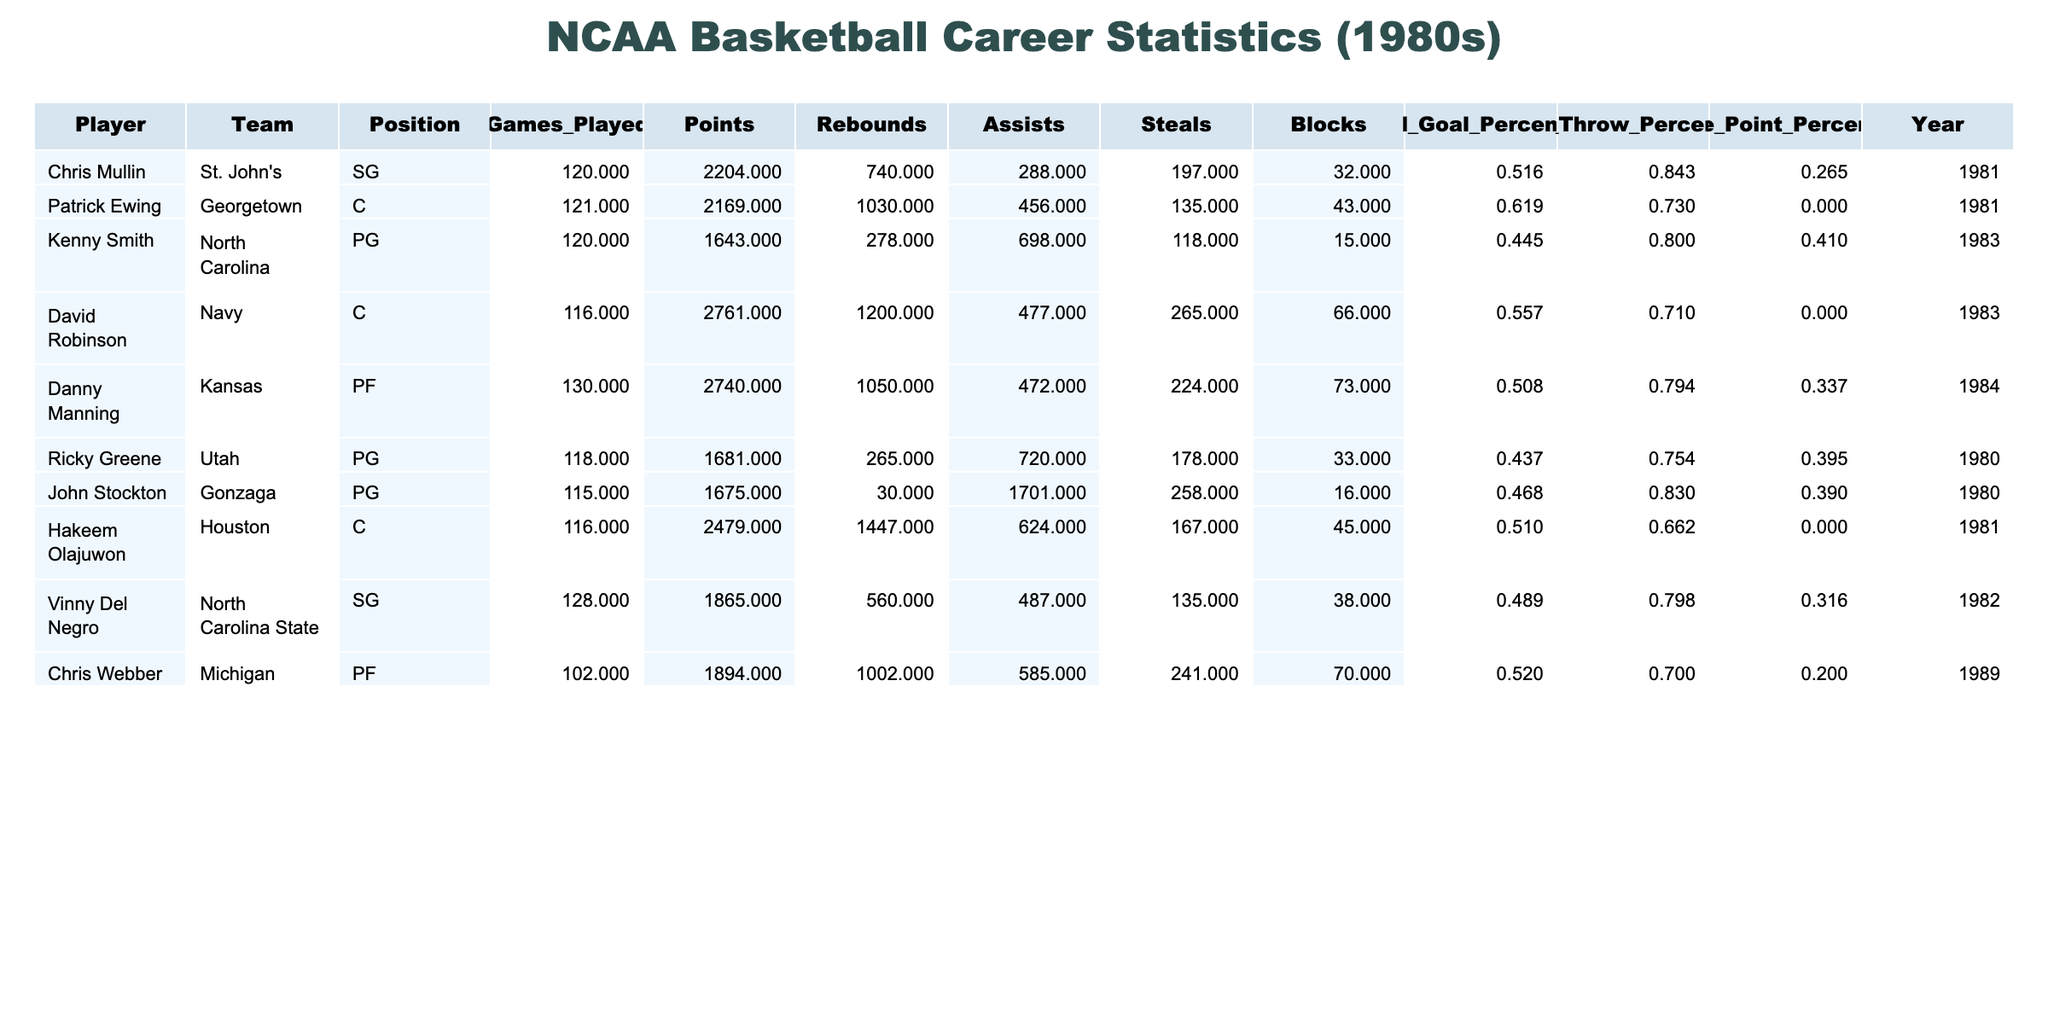What is the total number of points scored by David Robinson? David Robinson scored a total of 2761 points, which is listed in the table under the "Points" column for his entry.
Answer: 2761 Which player has the highest field goal percentage? Looking at the "Field_Goal_Percentage" column, Patrick Ewing has the highest field goal percentage of 0.619.
Answer: 0.619 How many rebounds did Chris Mullin record in his career? The table indicates that Chris Mullin recorded 740 rebounds, found in the "Rebounds" column for his entry.
Answer: 740 What is the average points scored by the players in this dataset? To find the average, we sum the points: (2204 + 2169 + 1643 + 2761 + 2740 + 1681 + 1675 + 2479 + 1865 + 1894) = 19655. There are 10 players, so the average is 19655/10 = 1965.5.
Answer: 1965.5 Did any player achieve a three-point percentage higher than 0.4? Looking at the "Three_Point_Percentage" column, Kenny Smith and Ricky Greene both scored above 0.4, thus the answer is yes.
Answer: Yes Which player recorded the most assists? By examining the "Assists" column, we see that John Stockton recorded the most assists with 1701.
Answer: 1701 What is the sum of rebounds by all the players listed? To find the total rebounds, we add: (740 + 456 + 278 + 1200 + 472 + 265 + 30 + 624 + 560 + 585) = 4680.
Answer: 4680 Which players had more than 1000 points and greater than 700 assists? Examining players, David Robinson (2761 points, 477 assists) qualifies but not others, because no one else meets the dual criteria.
Answer: David Robinson What is the median free throw percentage for the players? To find the median, we list the free throw percentages in order: [0.662, 0.710, 0.730, 0.794, 0.800, 0.843]. Since there are 10 entries, the median is the average of the 5th and 6th values: (0.794 + 0.800) / 2 = 0.797.
Answer: 0.797 How many players scored over 2000 points? In the "Points" column, we count the players with points greater than 2000, which are Chris Mullin, Patrick Ewing, David Robinson, and Danny Manning. Thus, there are 4 players.
Answer: 4 